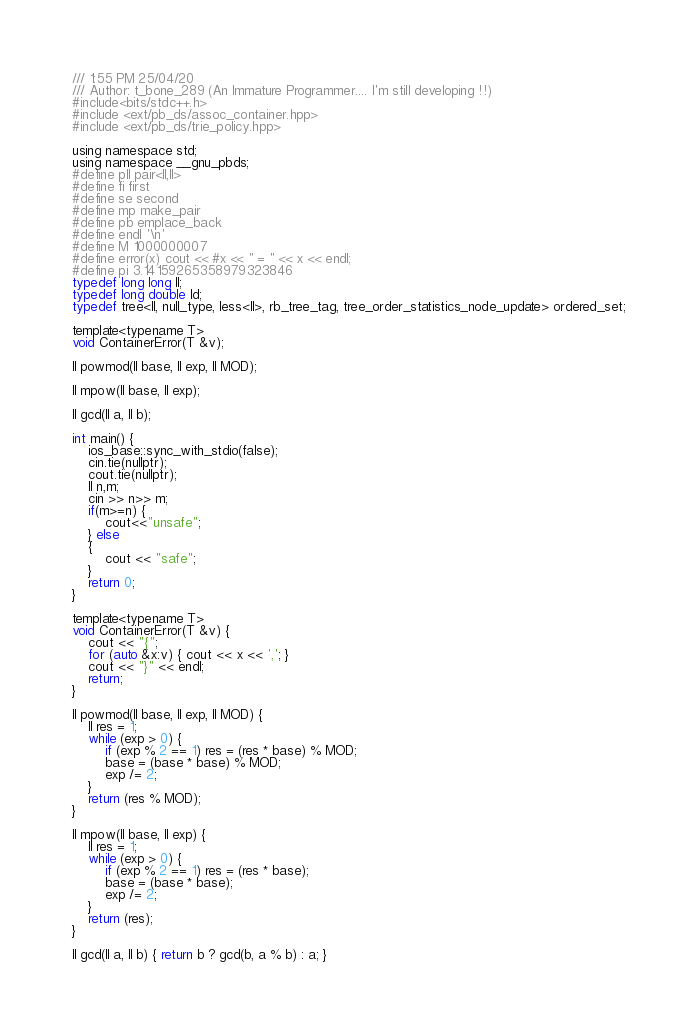Convert code to text. <code><loc_0><loc_0><loc_500><loc_500><_C_>/// 1:55 PM 25/04/20
/// Author: t_bone_289 (An Immature Programmer.... I'm still developing !!)
#include<bits/stdc++.h>
#include <ext/pb_ds/assoc_container.hpp>
#include <ext/pb_ds/trie_policy.hpp>

using namespace std;
using namespace __gnu_pbds;
#define pll pair<ll,ll>
#define fi first
#define se second
#define mp make_pair
#define pb emplace_back
#define endl '\n'
#define M 1000000007
#define error(x) cout << #x << " = " << x << endl;
#define pi 3.14159265358979323846
typedef long long ll;
typedef long double ld;
typedef tree<ll, null_type, less<ll>, rb_tree_tag, tree_order_statistics_node_update> ordered_set;

template<typename T>
void ContainerError(T &v);

ll powmod(ll base, ll exp, ll MOD);

ll mpow(ll base, ll exp);

ll gcd(ll a, ll b);

int main() {
    ios_base::sync_with_stdio(false);
    cin.tie(nullptr);
    cout.tie(nullptr);
    ll n,m;
    cin >> n>> m;
    if(m>=n) {
        cout<<"unsafe";
    } else
    {
        cout << "safe";
    }
    return 0;
}

template<typename T>
void ContainerError(T &v) {
    cout << "{";
    for (auto &x:v) { cout << x << ','; }
    cout << "}" << endl;
    return;
}

ll powmod(ll base, ll exp, ll MOD) {
    ll res = 1;
    while (exp > 0) {
        if (exp % 2 == 1) res = (res * base) % MOD;
        base = (base * base) % MOD;
        exp /= 2;
    }
    return (res % MOD);
}

ll mpow(ll base, ll exp) {
    ll res = 1;
    while (exp > 0) {
        if (exp % 2 == 1) res = (res * base);
        base = (base * base);
        exp /= 2;
    }
    return (res);
}

ll gcd(ll a, ll b) { return b ? gcd(b, a % b) : a; }

</code> 